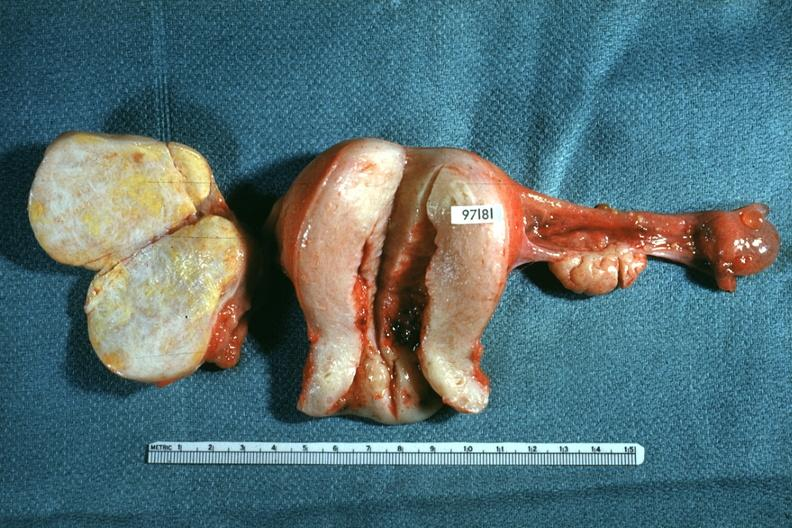s focal hemorrhagic infarction well shown present?
Answer the question using a single word or phrase. No 